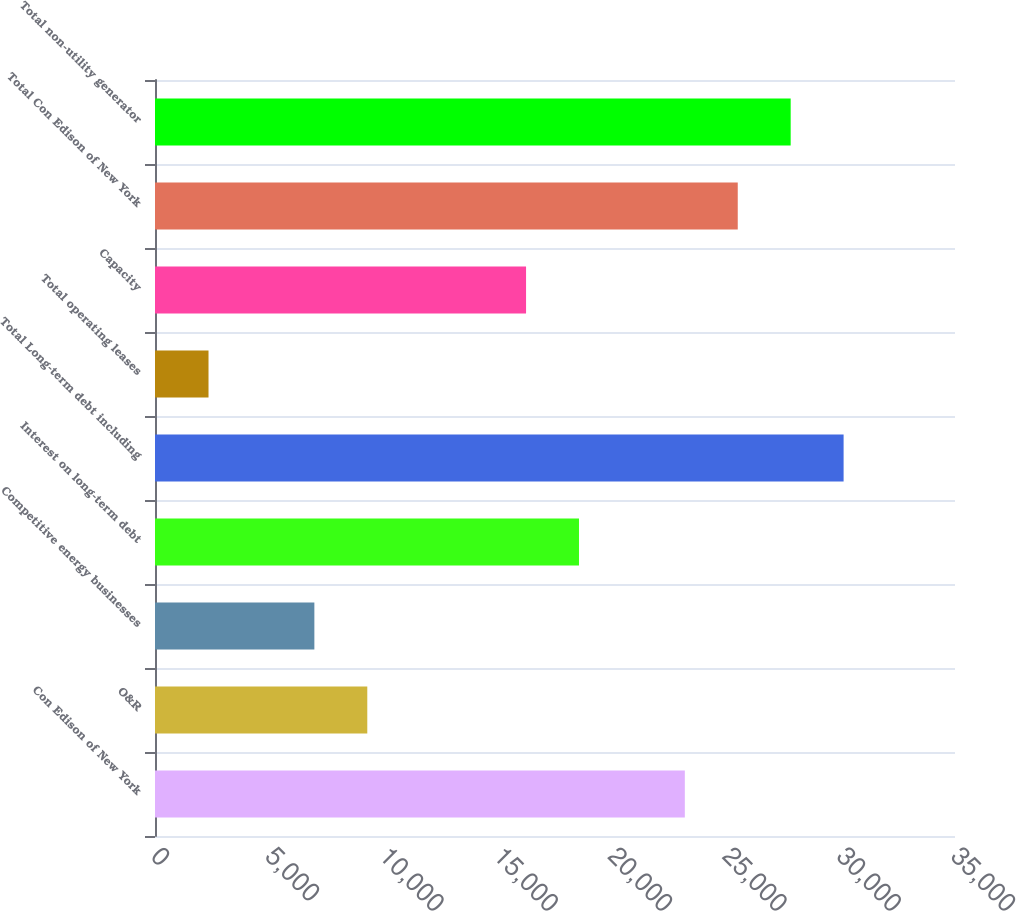<chart> <loc_0><loc_0><loc_500><loc_500><bar_chart><fcel>Con Edison of New York<fcel>O&R<fcel>Competitive energy businesses<fcel>Interest on long-term debt<fcel>Total Long-term debt including<fcel>Total operating leases<fcel>Capacity<fcel>Total Con Edison of New York<fcel>Total non-utility generator<nl><fcel>23180<fcel>9287.6<fcel>6972.2<fcel>18549.2<fcel>30126.2<fcel>2341.4<fcel>16233.8<fcel>25495.4<fcel>27810.8<nl></chart> 